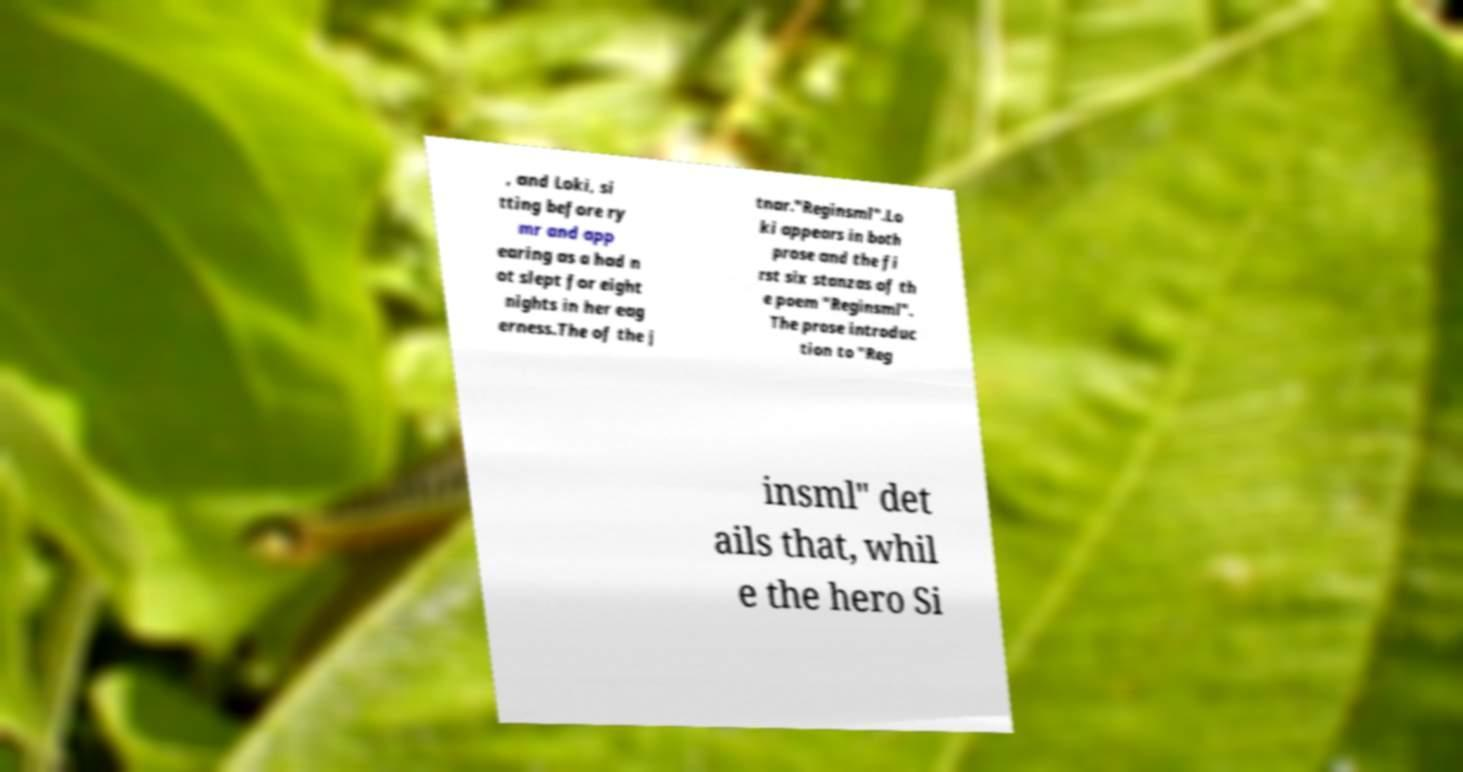What messages or text are displayed in this image? I need them in a readable, typed format. , and Loki, si tting before ry mr and app earing as a had n ot slept for eight nights in her eag erness.The of the j tnar."Reginsml".Lo ki appears in both prose and the fi rst six stanzas of th e poem "Reginsml". The prose introduc tion to "Reg insml" det ails that, whil e the hero Si 